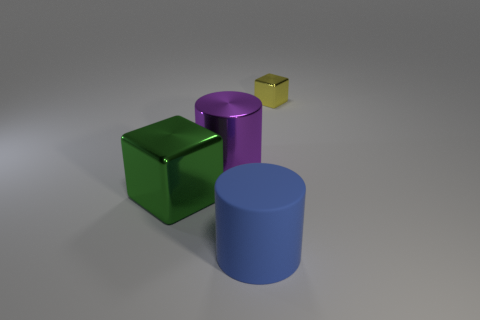Add 1 green objects. How many objects exist? 5 Add 4 big blue cylinders. How many big blue cylinders are left? 5 Add 4 green metal balls. How many green metal balls exist? 4 Subtract 0 green cylinders. How many objects are left? 4 Subtract all green metal objects. Subtract all large blue rubber cylinders. How many objects are left? 2 